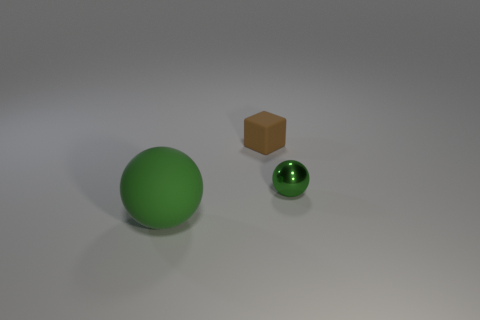Add 2 brown things. How many objects exist? 5 Subtract all spheres. How many objects are left? 1 Subtract 0 purple spheres. How many objects are left? 3 Subtract all tiny cyan things. Subtract all small cubes. How many objects are left? 2 Add 2 green shiny objects. How many green shiny objects are left? 3 Add 1 green metallic balls. How many green metallic balls exist? 2 